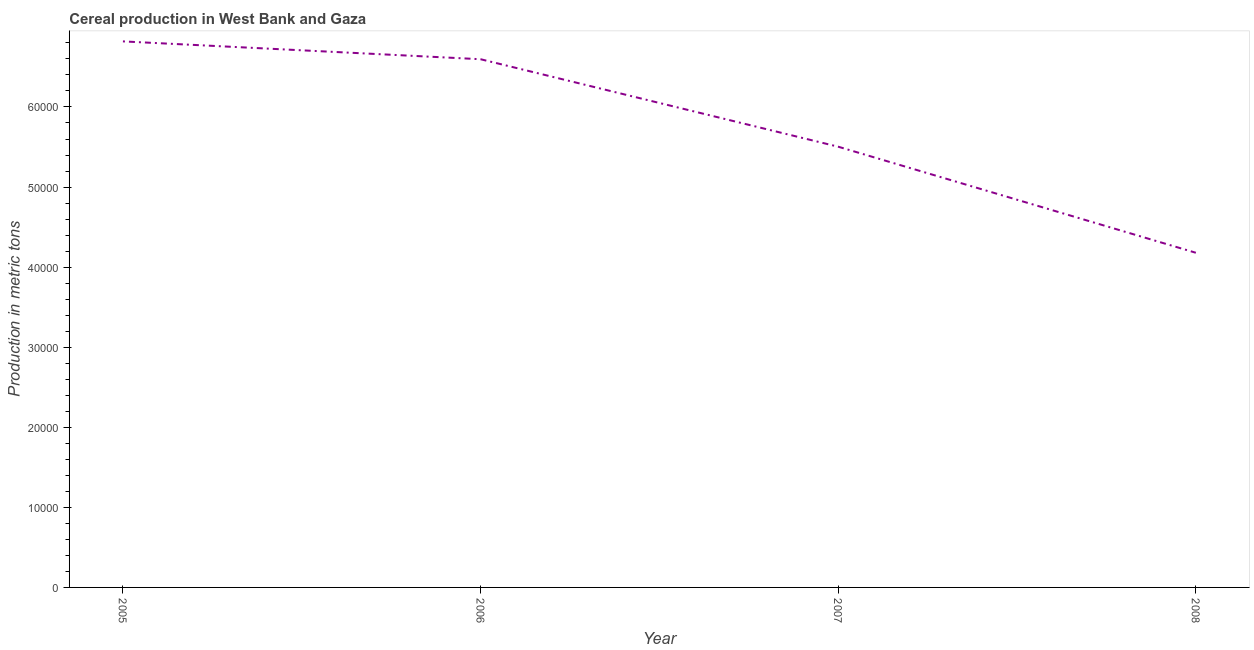What is the cereal production in 2006?
Your response must be concise. 6.60e+04. Across all years, what is the maximum cereal production?
Your answer should be very brief. 6.82e+04. Across all years, what is the minimum cereal production?
Provide a succinct answer. 4.18e+04. In which year was the cereal production maximum?
Give a very brief answer. 2005. In which year was the cereal production minimum?
Give a very brief answer. 2008. What is the sum of the cereal production?
Make the answer very short. 2.31e+05. What is the difference between the cereal production in 2005 and 2007?
Your response must be concise. 1.32e+04. What is the average cereal production per year?
Ensure brevity in your answer.  5.77e+04. What is the median cereal production?
Provide a short and direct response. 6.05e+04. What is the ratio of the cereal production in 2005 to that in 2008?
Ensure brevity in your answer.  1.63. Is the cereal production in 2006 less than that in 2007?
Your answer should be compact. No. What is the difference between the highest and the second highest cereal production?
Provide a short and direct response. 2227. What is the difference between the highest and the lowest cereal production?
Provide a succinct answer. 2.64e+04. In how many years, is the cereal production greater than the average cereal production taken over all years?
Make the answer very short. 2. Does the cereal production monotonically increase over the years?
Your response must be concise. No. How many lines are there?
Your answer should be compact. 1. What is the difference between two consecutive major ticks on the Y-axis?
Offer a terse response. 10000. Are the values on the major ticks of Y-axis written in scientific E-notation?
Offer a terse response. No. What is the title of the graph?
Your answer should be very brief. Cereal production in West Bank and Gaza. What is the label or title of the Y-axis?
Your answer should be compact. Production in metric tons. What is the Production in metric tons of 2005?
Offer a very short reply. 6.82e+04. What is the Production in metric tons of 2006?
Your answer should be compact. 6.60e+04. What is the Production in metric tons of 2007?
Your response must be concise. 5.50e+04. What is the Production in metric tons of 2008?
Provide a succinct answer. 4.18e+04. What is the difference between the Production in metric tons in 2005 and 2006?
Provide a succinct answer. 2227. What is the difference between the Production in metric tons in 2005 and 2007?
Your response must be concise. 1.32e+04. What is the difference between the Production in metric tons in 2005 and 2008?
Your response must be concise. 2.64e+04. What is the difference between the Production in metric tons in 2006 and 2007?
Your response must be concise. 1.09e+04. What is the difference between the Production in metric tons in 2006 and 2008?
Ensure brevity in your answer.  2.42e+04. What is the difference between the Production in metric tons in 2007 and 2008?
Provide a short and direct response. 1.32e+04. What is the ratio of the Production in metric tons in 2005 to that in 2006?
Keep it short and to the point. 1.03. What is the ratio of the Production in metric tons in 2005 to that in 2007?
Ensure brevity in your answer.  1.24. What is the ratio of the Production in metric tons in 2005 to that in 2008?
Offer a very short reply. 1.63. What is the ratio of the Production in metric tons in 2006 to that in 2007?
Provide a succinct answer. 1.2. What is the ratio of the Production in metric tons in 2006 to that in 2008?
Provide a short and direct response. 1.58. What is the ratio of the Production in metric tons in 2007 to that in 2008?
Offer a very short reply. 1.32. 